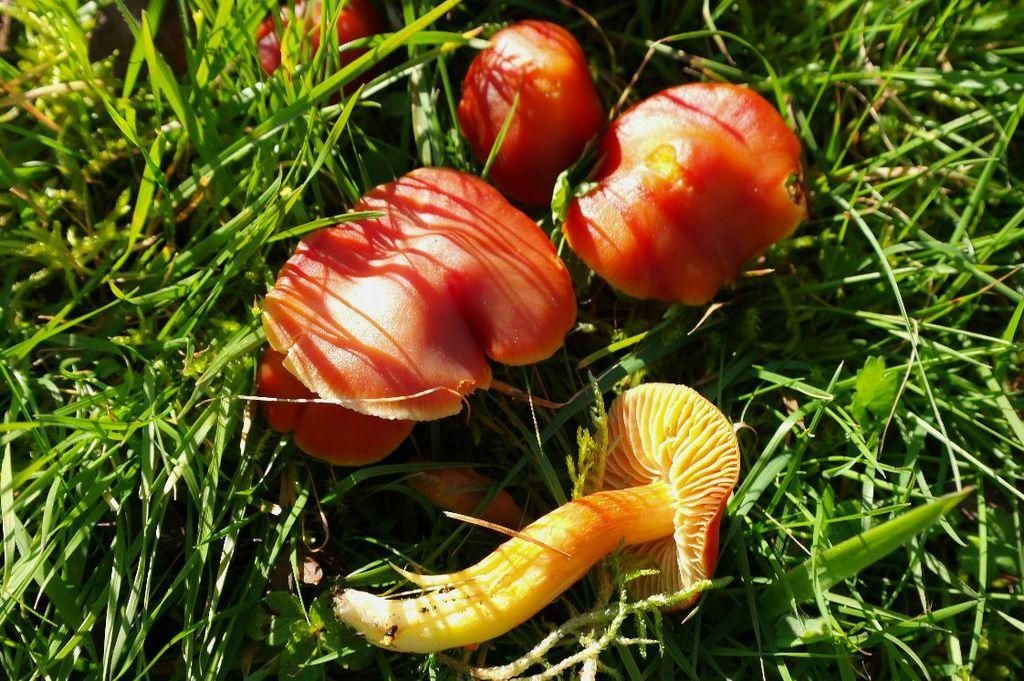What type of fungi can be seen in the image? There are mushrooms in the image. What colors are the mushrooms? The mushrooms are red, yellow, and orange in color. Where are the mushrooms located? The mushrooms are in the grass. What color is the grass? The grass is green in color. On what surface is the grass located? The grass is on the ground. Are there any apples growing on the donkey in the image? There is no donkey or apple tree present in the image, so it is not possible to answer that question. 